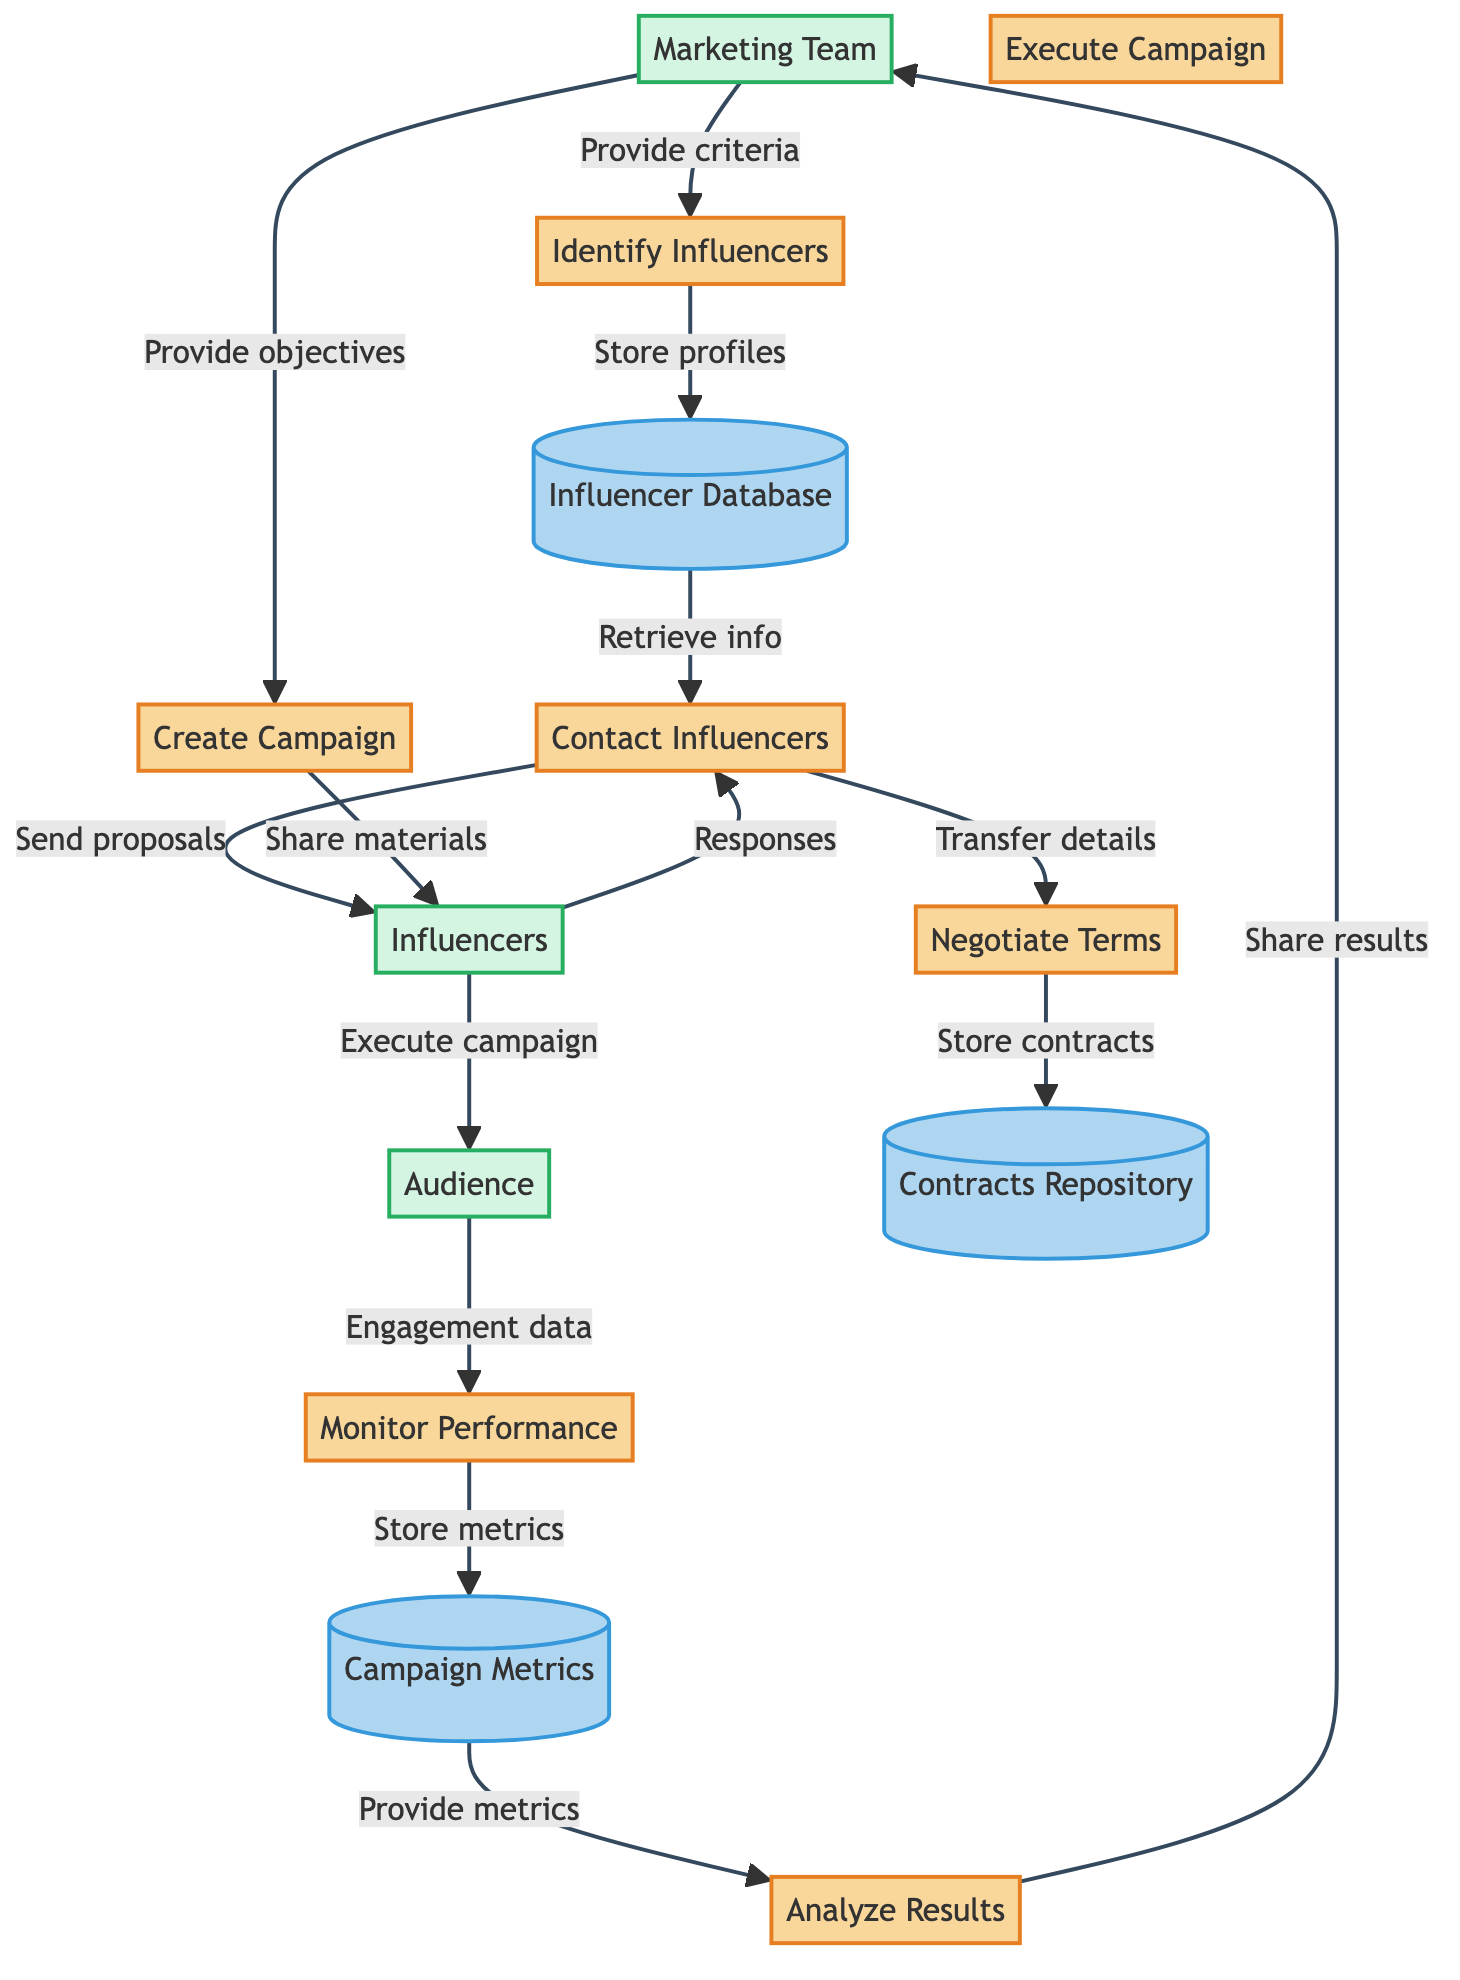What is the first process in the diagram? The first process listed in the diagram is "Identify Influencers," which is the starting point for the influencer collaboration strategy.
Answer: Identify Influencers How many data stores are present in the diagram? The diagram contains three data stores: "Influencer Database," "Contracts Repository," and "Campaign Metrics." Therefore, the count is three.
Answer: 3 Which entity is responsible for providing criteria for influencer selection? The "Marketing Team" is the entity that provides criteria for influencer selection to the "Identify Influencers" process, as indicated by the directed flow from the Marketing Team to the first process.
Answer: Marketing Team What happens after the "Execute Campaign" process? Following the "Execute Campaign" process, the next step is to engage the "Audience," where the campaign is promoted directly to them. This indicates the continuation of the flow after execution.
Answer: Audience How does the "Negotiate Terms" process interact with the "Contracts Repository"? The "Negotiate Terms" process transfers finalized contracts to the "Contracts Repository," indicating that this data store is where the agreements are stored once negotiations are complete.
Answer: Store contracts What type of data is transferred from "Monitor Performance" to "Campaign Metrics"? The data being stored in "Campaign Metrics" is performance metrics derived from the monitoring conducted in the "Monitor Performance" process, which aggregates audience engagement data.
Answer: Store performance metrics Which process directly shares materials with influencers? The "Create Campaign" process is responsible for sharing campaign materials with the "Influencers," as indicated by the flow from Create Campaign to Influencers in the diagram.
Answer: Create Campaign How many steps involve the "Influencers" entity directly? The "Influencers" entity is involved directly in four steps: receiving collaboration proposals, responding, sharing campaign materials, and executing the campaign, thus summing up to four interactions.
Answer: 4 What kind of metrics does "Analyze Results" use for its analysis? The "Analyze Results" process utilizes the metrics provided from the "Campaign Metrics" data store to conduct its analysis, indicating that it relies on quantitative performance data.
Answer: Metrics for analysis 